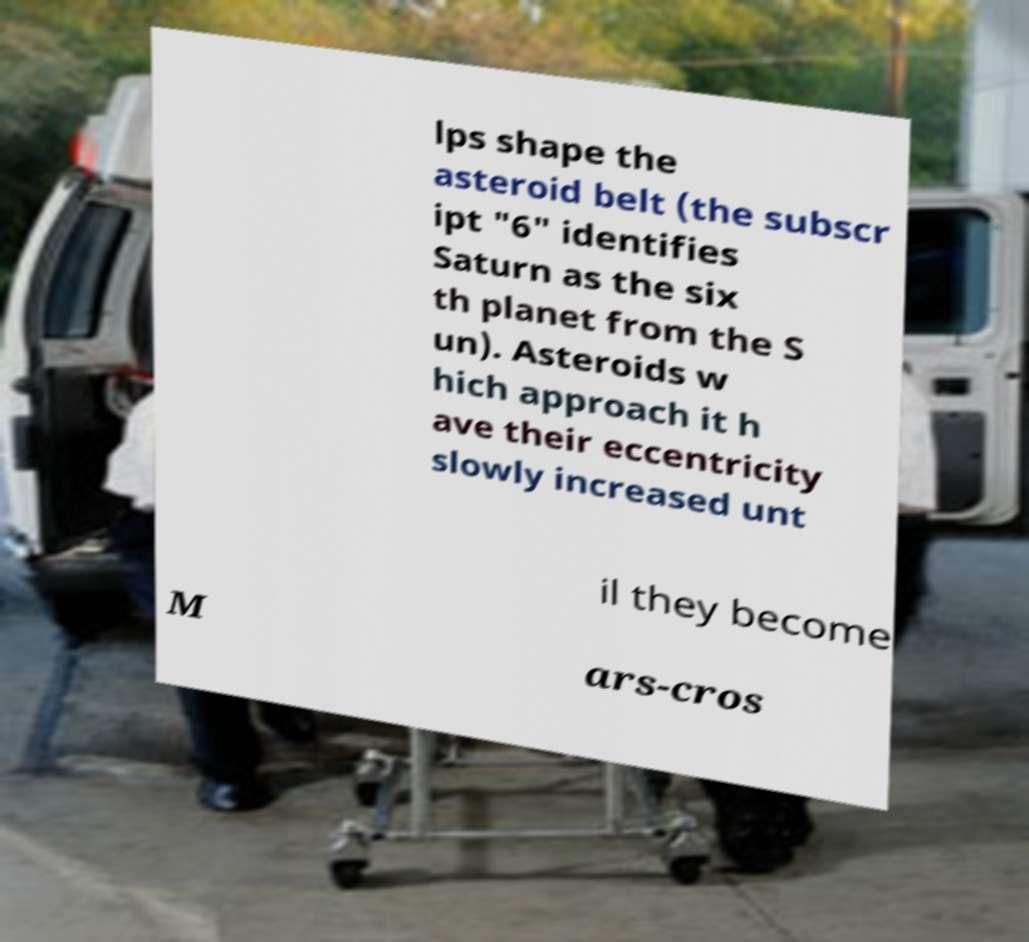Can you read and provide the text displayed in the image?This photo seems to have some interesting text. Can you extract and type it out for me? lps shape the asteroid belt (the subscr ipt "6" identifies Saturn as the six th planet from the S un). Asteroids w hich approach it h ave their eccentricity slowly increased unt il they become M ars-cros 